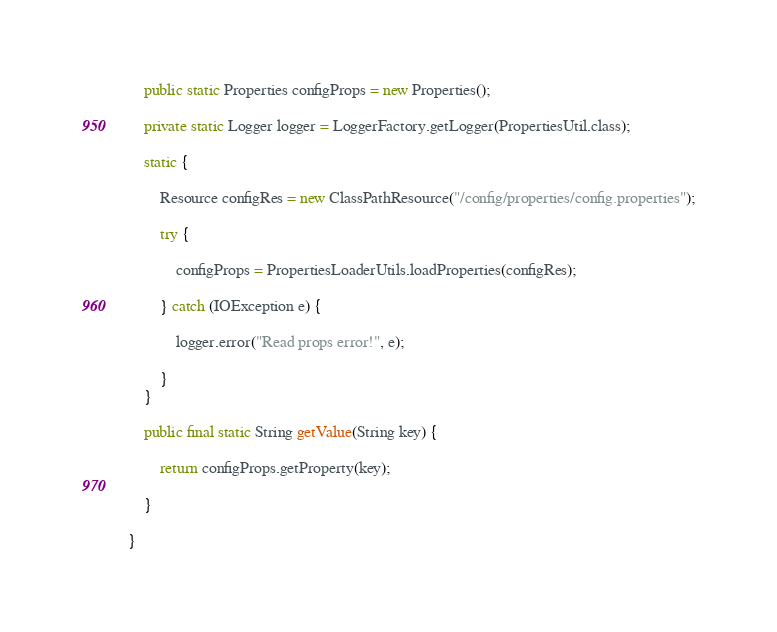Convert code to text. <code><loc_0><loc_0><loc_500><loc_500><_Java_>
	public static Properties configProps = new Properties();

	private static Logger logger = LoggerFactory.getLogger(PropertiesUtil.class);

	static {
		
		Resource configRes = new ClassPathResource("/config/properties/config.properties");

		try {
			
			configProps = PropertiesLoaderUtils.loadProperties(configRes);

		} catch (IOException e) {

			logger.error("Read props error!", e);
			
		}
	}

	public final static String getValue(String key) {
		
		return configProps.getProperty(key);
		
	}

}

</code> 